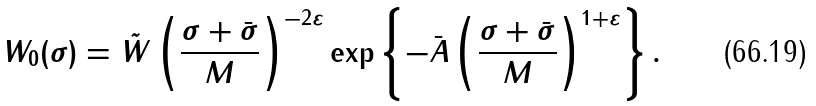<formula> <loc_0><loc_0><loc_500><loc_500>W _ { 0 } ( \sigma ) = \tilde { W } \left ( \frac { \sigma + \bar { \sigma } } { M } \right ) ^ { - 2 \varepsilon } \exp \left \{ - \bar { A } \left ( \frac { \sigma + \bar { \sigma } } { M } \right ) ^ { 1 + \varepsilon } \right \} .</formula> 